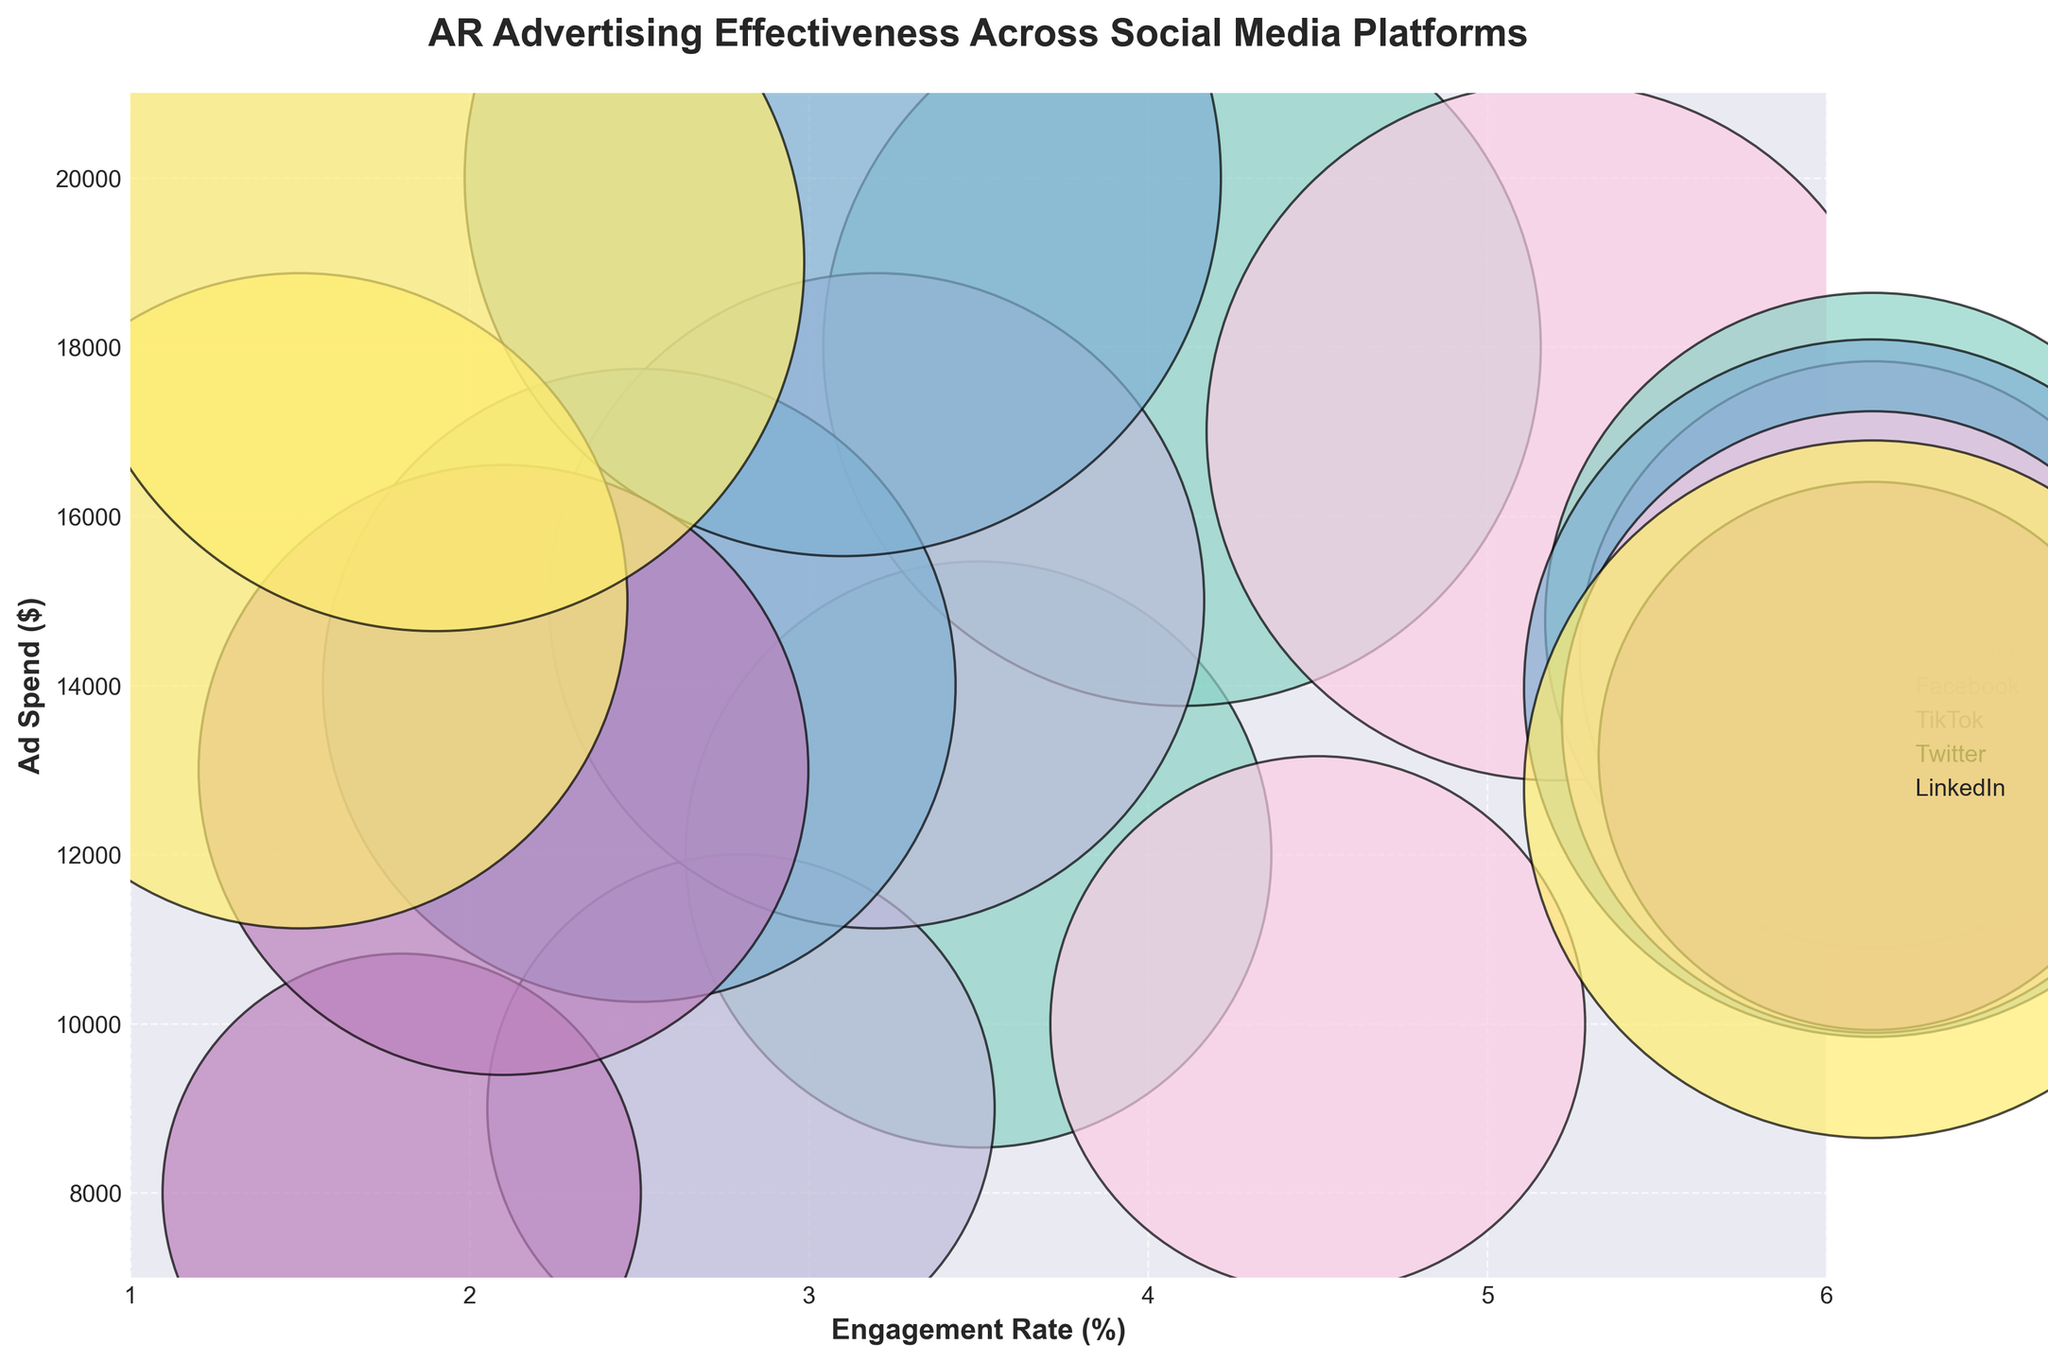Which platform has the highest engagement rate? Look at the x-axis to find the data points with the highest engagement rate. TikTok has the highest engagement rate with 5.2%.
Answer: TikTok What is the title of the chart? The title is located at the top of the chart and provides a summary of the figure. It reads "AR Advertising Effectiveness Across Social Media Platforms."
Answer: AR Advertising Effectiveness Across Social Media Platforms How does the engagement rate of Facebook compare to Twitter? Look at the x-axis for the engagement rates of both platforms. Facebook has engagement rates of 2.5% and 3.1%, while Twitter has engagement rates of 1.8% and 2.1%. Facebook has higher engagement rates than Twitter.
Answer: Facebook has higher engagement rates What's the relationship between ad spend and engagement rate for Instagram? Look at the data points for Instagram and observe their positions in relation to the x-axis (engagement rate) and y-axis (ad spend). As the ad spend increases from $12,000 to $18,000, the engagement rate also increases from 3.5% to 4.1%.
Answer: Positive correlation Which social media platform has the lowest ad spend for an engagement rate above 4%? Identify the data points with engagement rates above 4% and compare their ad spend. TikTok has an engagement rate of 4.5% at an ad spend of $10,000, which is the lowest among those points.
Answer: TikTok What's the average ad spend for Snapchat? Look at the y-axis values for data points related to Snapchat, which are $9000 and $15000. Calculate the average ad spend as (9000 + 15000) / 2.
Answer: $12,000 Which platform has the most significant variance in ad spend? Compare the range of ad spend values for each platform. Facebook varies from $14,000 to $20,000, which is the most significant variance.
Answer: Facebook Is there any platform with data points clustered close together? Look for platforms whose data points are positioned closely on both axes. LinkedIn's data points (1.5%, $15,000) and (1.9%, $19,000) are relatively close in both engagement rate and ad spend.
Answer: LinkedIn Which platform has a bubble size that indicates the highest ad spend? Observe the bubble sizes across all platforms. Facebook has the largest bubble, indicating the highest ad spend of $20,000.
Answer: Facebook 